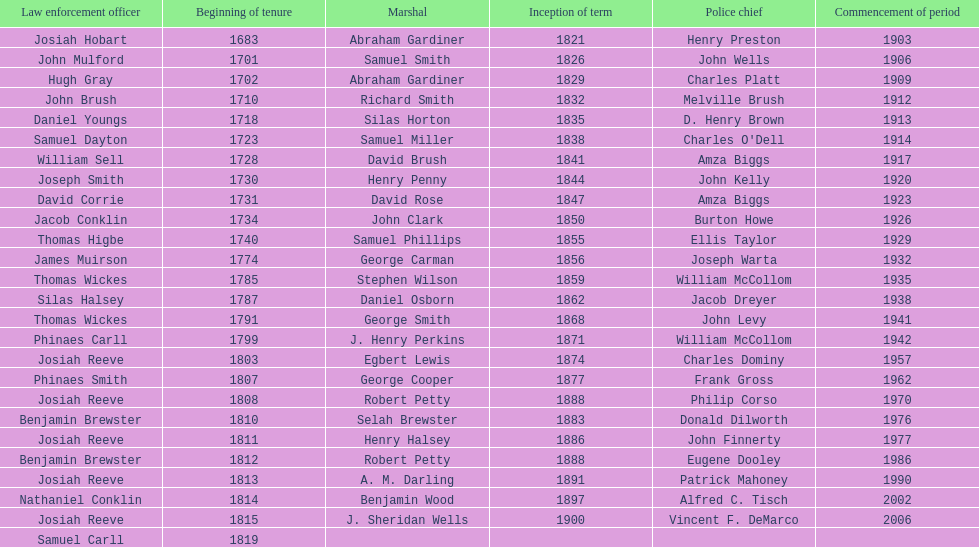Who was the sheriff in suffolk county before amza biggs first term there as sheriff? Charles O'Dell. 